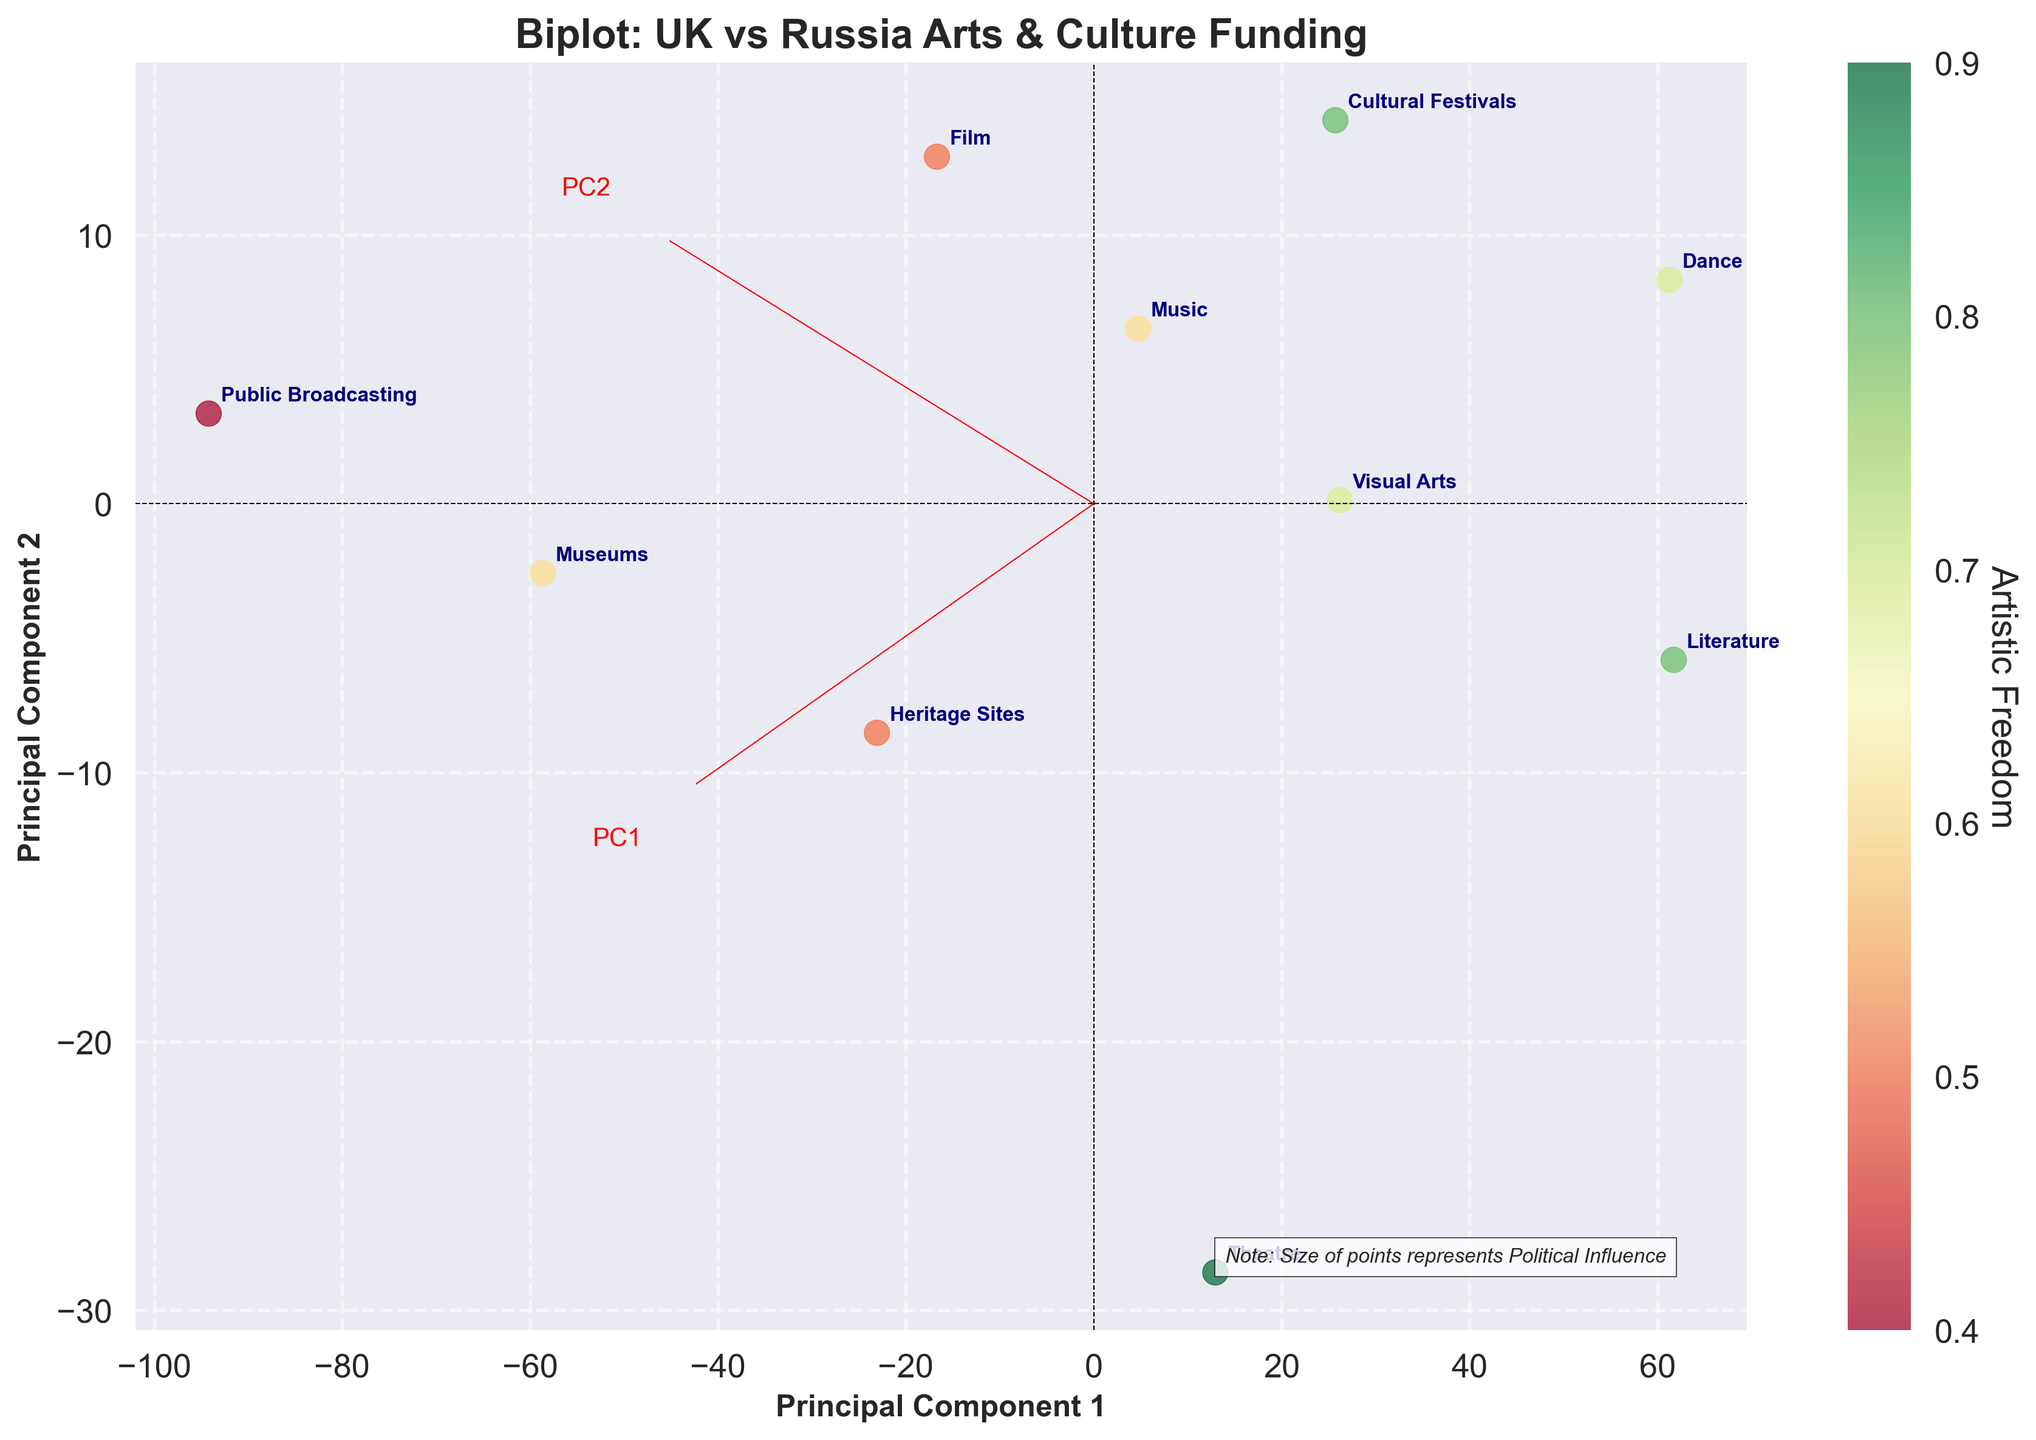What is the title of the biplot? The title of a plot provides context and focus for what the viewer is examining. Here, the title text is located at the top of the figure.
Answer: Biplot: UK vs Russia Arts & Culture Funding How is 'Artistic Freedom' represented in the biplot? In the plot, 'Artistic Freedom' is represented by the color of the points. A colorbar at the side of the plot maps the different colors to the respective values of 'Artistic Freedom'.
Answer: By the color of the points Which category has the highest artistic freedom? Look at the colorbar to interpret the gradient values and then identify the points with the highest corresponding color for 'Artistic Freedom'. Annotated points help in identifying the categories.
Answer: Theatre Which principal component axis influences 'Public Broadcasting' the most? Observe the positions of eigenvectors labeled PC1 and PC2, and see how the 'Public Broadcasting' point aligns with these axes. This should clarify the dominant influence.
Answer: PC1 How many categories have higher artistic freedom in the UK compared to Russia? Identify and compare the point annotations with higher artistic freedom values from the colorbar. Visually, the more greenish points (indicating higher values) should be counted.
Answer: 10 categories Which category does 'PC2' have a significant impact on? Examine how much categories deviate along the PC2 axis. A category farthest along this axis is the one dramatically influenced by PC2.
Answer: Dance How does 'Political Influence' vary among different points in the plot? The note at the bottom informs that the size of points reflects 'Political Influence'. Larger points exhibit more political influence.
Answer: By the size of points What is the clustering pattern of UK vs Russia funding for 'Film' and 'Music'? Check the positions of 'Film' and 'Music' categories on the PC axes. Analyze how close or separated these categories are from each other to determine clustering.
Answer: Close together Which categories show the highest and lowest variation along Principal Component 1? Identify the categories farthest left and right along the PC1 axis on the plot. This will reveal the highest and lowest variations along PC1.
Answer: Public Broadcasting (highest), Dance (lowest) How can you infer the level of political influence for 'Literature' in the plot? Examine the size of the 'Literature' point. According to the note, larger points indicate more political influence. Determine its comparative size.
Answer: Low political influence 